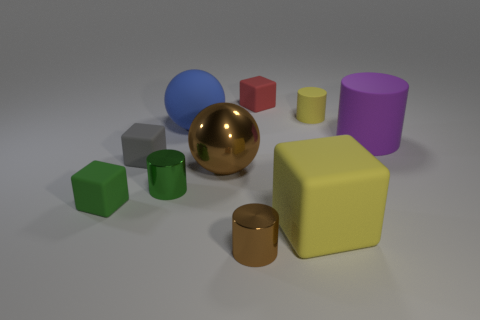Does the brown shiny object that is in front of the large brown sphere have the same size as the rubber cylinder that is behind the blue matte sphere? Upon observing the spatial relations and apparent sizes, it is not accurate to assert that they are the same size; the brown shiny cylinder in front of the large brown sphere appears to be larger in diameter compared to the yellow cylinder behind the blue matte sphere. 